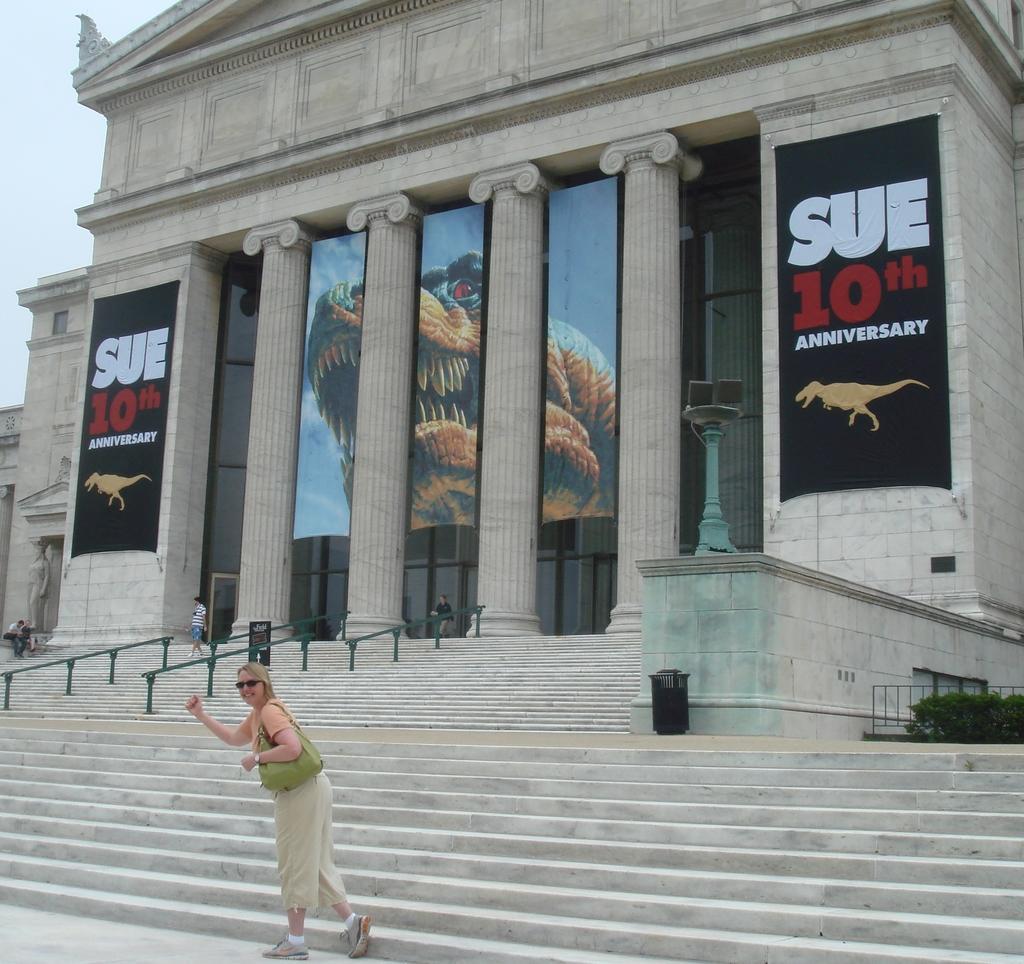Can you describe this image briefly? This picture is clicked outside. In the foreground there is a woman wearing a sling bag and walking on the ground. In the background there is a sky and we can see the building, pillars and some sculptures and we can see the banners on which we can see the text and some pictures and there are some objects and we can see the plants and stairs and handrails. 